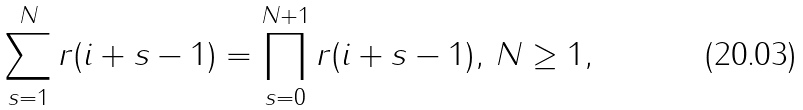<formula> <loc_0><loc_0><loc_500><loc_500>\sum _ { s = 1 } ^ { N } r ( i + s - 1 ) = \prod _ { s = 0 } ^ { N + 1 } r ( i + s - 1 ) , \, N \geq 1 ,</formula> 